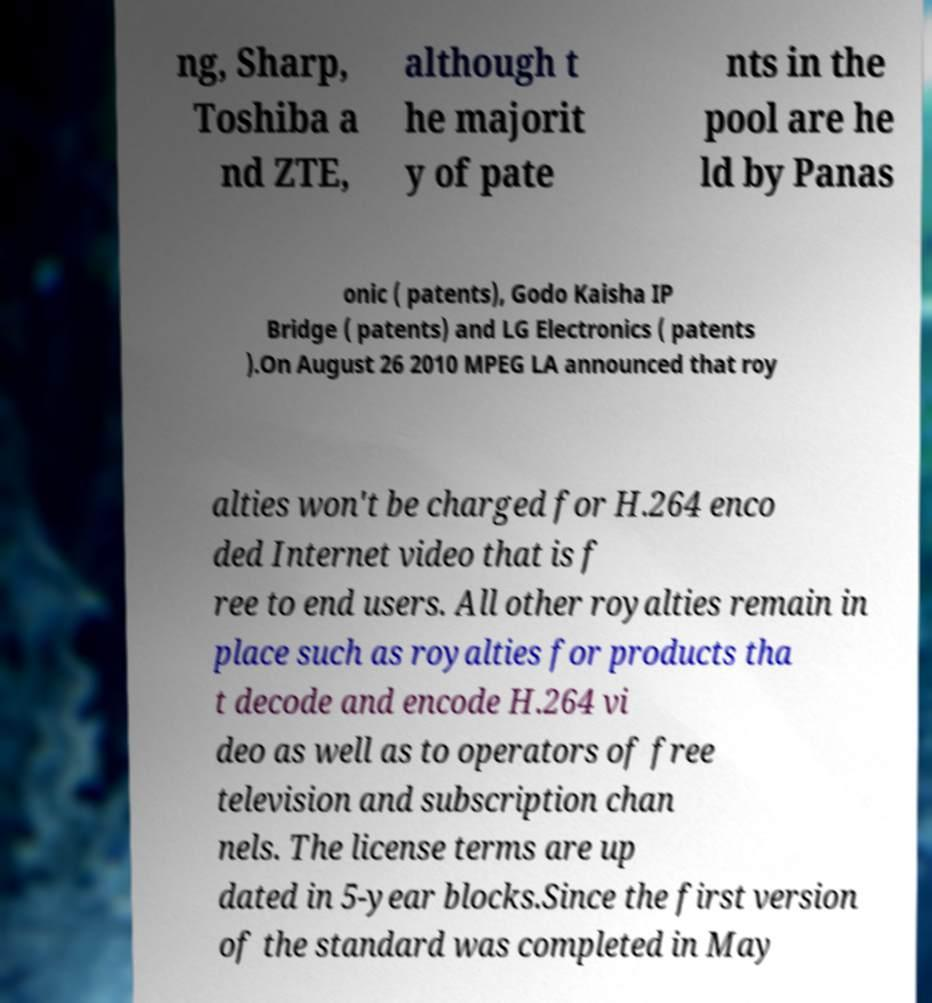What messages or text are displayed in this image? I need them in a readable, typed format. ng, Sharp, Toshiba a nd ZTE, although t he majorit y of pate nts in the pool are he ld by Panas onic ( patents), Godo Kaisha IP Bridge ( patents) and LG Electronics ( patents ).On August 26 2010 MPEG LA announced that roy alties won't be charged for H.264 enco ded Internet video that is f ree to end users. All other royalties remain in place such as royalties for products tha t decode and encode H.264 vi deo as well as to operators of free television and subscription chan nels. The license terms are up dated in 5-year blocks.Since the first version of the standard was completed in May 